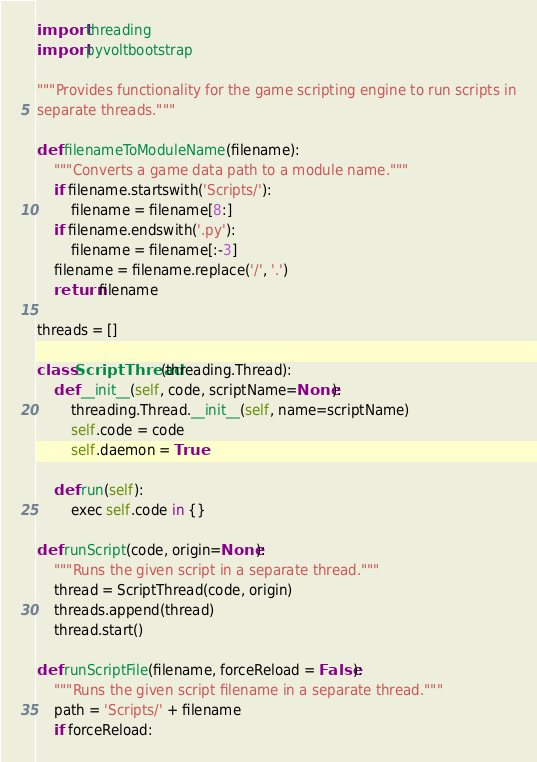<code> <loc_0><loc_0><loc_500><loc_500><_Python_>import threading
import pyvoltbootstrap

"""Provides functionality for the game scripting engine to run scripts in
separate threads."""

def filenameToModuleName(filename):
    """Converts a game data path to a module name."""
    if filename.startswith('Scripts/'):
        filename = filename[8:]
    if filename.endswith('.py'):
        filename = filename[:-3]
    filename = filename.replace('/', '.')
    return filename

threads = []

class ScriptThread(threading.Thread):
    def __init__(self, code, scriptName=None):
        threading.Thread.__init__(self, name=scriptName)
        self.code = code
        self.daemon = True

    def run(self):
        exec self.code in {}

def runScript(code, origin=None):
    """Runs the given script in a separate thread."""
    thread = ScriptThread(code, origin)
    threads.append(thread)
    thread.start()

def runScriptFile(filename, forceReload = False):
    """Runs the given script filename in a separate thread."""
    path = 'Scripts/' + filename
    if forceReload:</code> 